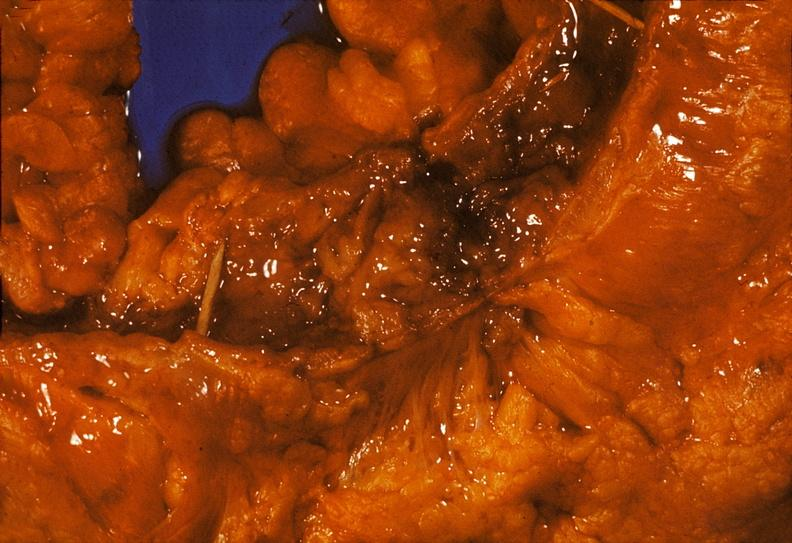what is present?
Answer the question using a single word or phrase. Gastrointestinal 